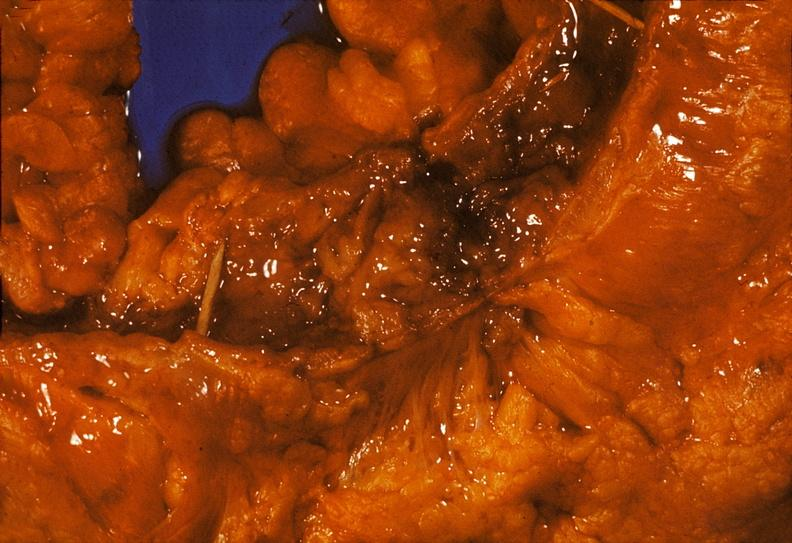what is present?
Answer the question using a single word or phrase. Gastrointestinal 